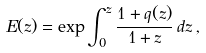Convert formula to latex. <formula><loc_0><loc_0><loc_500><loc_500>E ( z ) = \exp { \int _ { 0 } ^ { z } \frac { 1 + q ( z ) } { 1 + z } \, d z } \, ,</formula> 